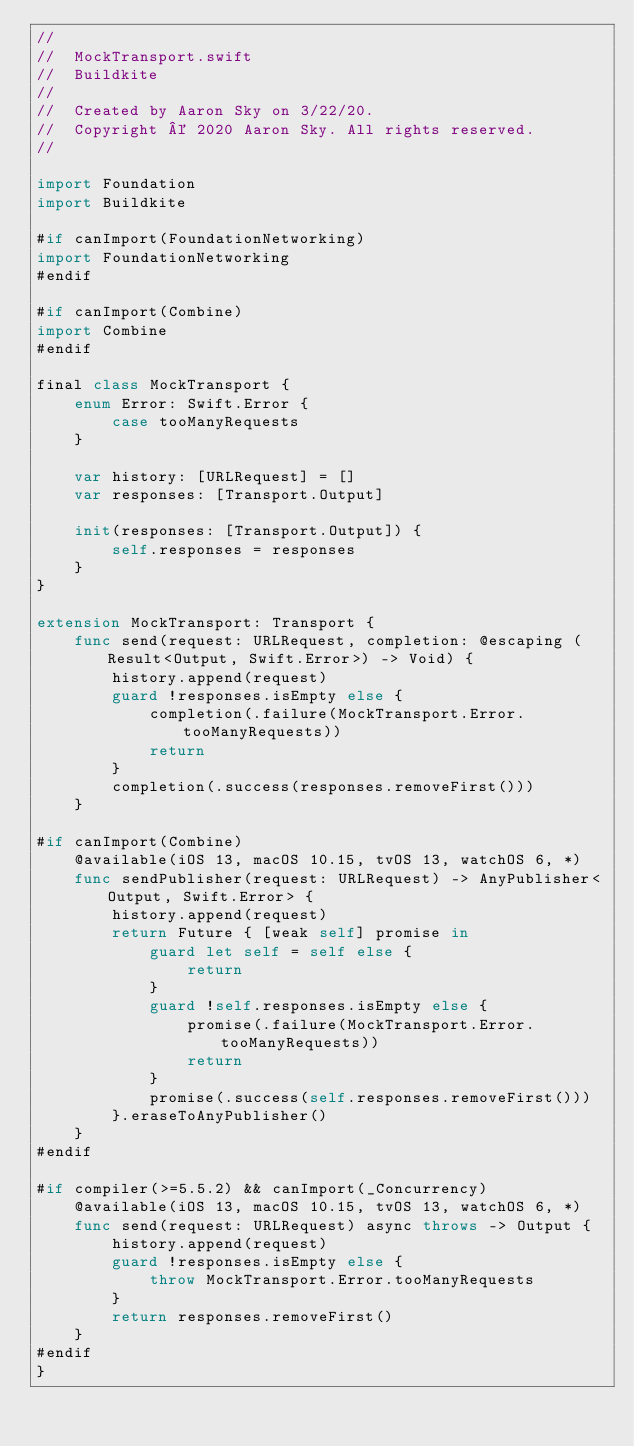<code> <loc_0><loc_0><loc_500><loc_500><_Swift_>//
//  MockTransport.swift
//  Buildkite
//
//  Created by Aaron Sky on 3/22/20.
//  Copyright © 2020 Aaron Sky. All rights reserved.
//

import Foundation
import Buildkite

#if canImport(FoundationNetworking)
import FoundationNetworking
#endif

#if canImport(Combine)
import Combine
#endif

final class MockTransport {
    enum Error: Swift.Error {
        case tooManyRequests
    }

    var history: [URLRequest] = []
    var responses: [Transport.Output]

    init(responses: [Transport.Output]) {
        self.responses = responses
    }
}

extension MockTransport: Transport {
    func send(request: URLRequest, completion: @escaping (Result<Output, Swift.Error>) -> Void) {
        history.append(request)
        guard !responses.isEmpty else {
            completion(.failure(MockTransport.Error.tooManyRequests))
            return
        }
        completion(.success(responses.removeFirst()))
    }

#if canImport(Combine)
    @available(iOS 13, macOS 10.15, tvOS 13, watchOS 6, *)
    func sendPublisher(request: URLRequest) -> AnyPublisher<Output, Swift.Error> {
        history.append(request)
        return Future { [weak self] promise in
            guard let self = self else {
                return
            }
            guard !self.responses.isEmpty else {
                promise(.failure(MockTransport.Error.tooManyRequests))
                return
            }
            promise(.success(self.responses.removeFirst()))
        }.eraseToAnyPublisher()
    }
#endif

#if compiler(>=5.5.2) && canImport(_Concurrency)
    @available(iOS 13, macOS 10.15, tvOS 13, watchOS 6, *)
    func send(request: URLRequest) async throws -> Output {
        history.append(request)
        guard !responses.isEmpty else {
            throw MockTransport.Error.tooManyRequests
        }
        return responses.removeFirst()
    }
#endif
}
</code> 